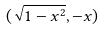<formula> <loc_0><loc_0><loc_500><loc_500>( \sqrt { 1 - x ^ { 2 } } , - x )</formula> 